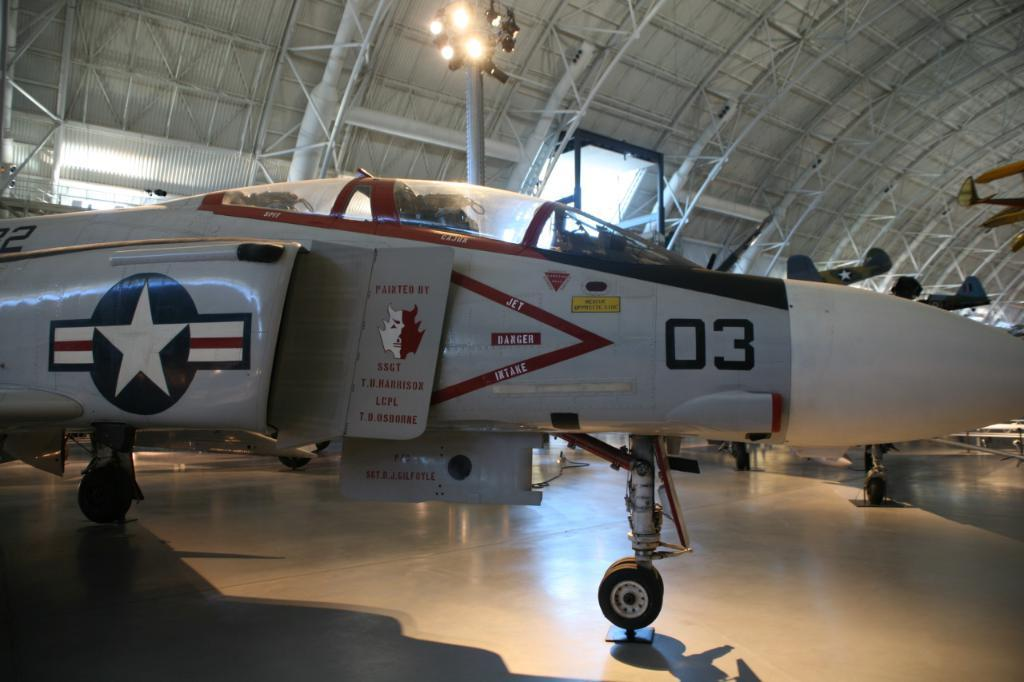What is placed on the floor in the image? There is an aircraft on the floor in the image. What can be seen in the background of the image? There is a light pole in the background of the image. What is visible at the top of the image? There is a roof visible at the top of the image. Where is the shelf located in the image? There is no shelf present in the image. What type of plough can be seen in the image? There is no plough present in the image. 